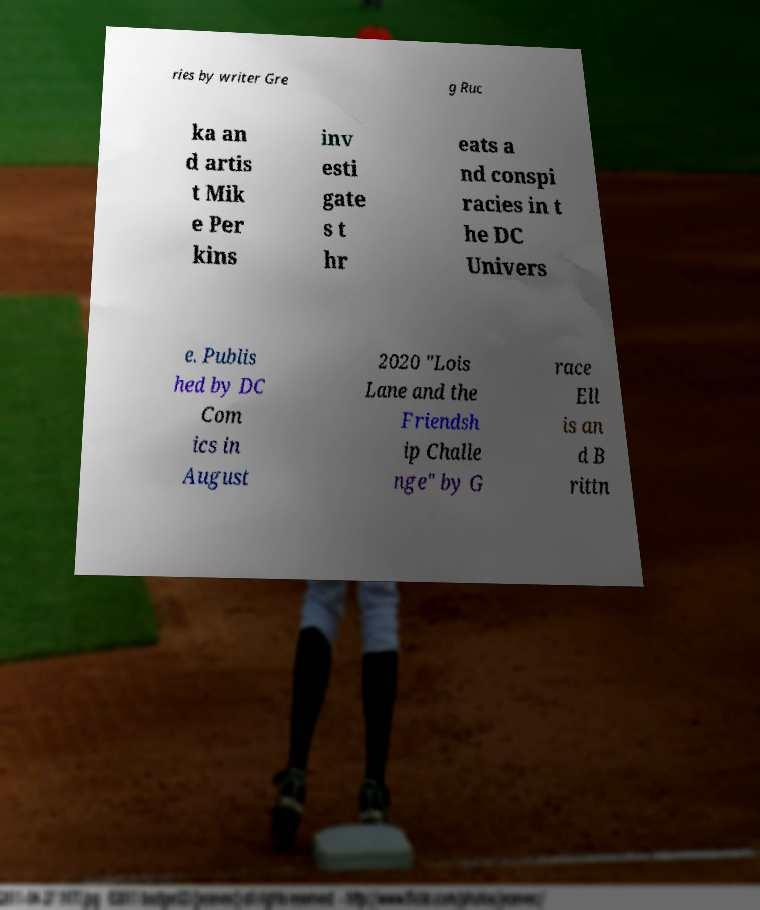What messages or text are displayed in this image? I need them in a readable, typed format. ries by writer Gre g Ruc ka an d artis t Mik e Per kins inv esti gate s t hr eats a nd conspi racies in t he DC Univers e. Publis hed by DC Com ics in August 2020 "Lois Lane and the Friendsh ip Challe nge" by G race Ell is an d B rittn 